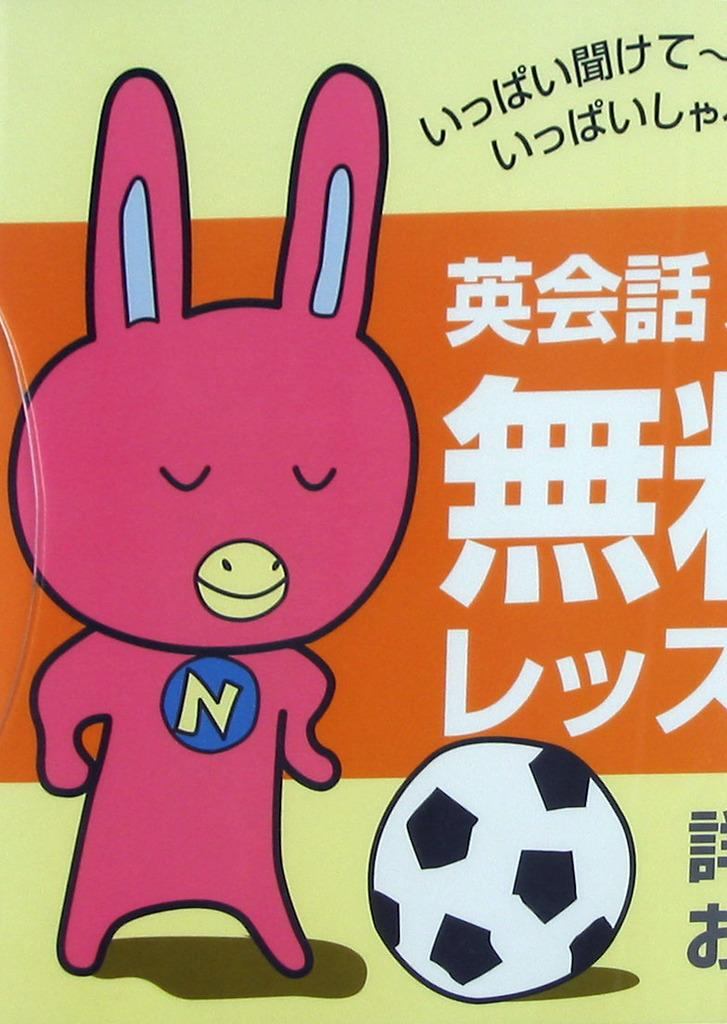What is present on the poster in the image? There is a poster in the image, which contains text and an image. Can you describe the image on the poster? Unfortunately, the facts provided do not give any details about the image on the poster. What type of information might be conveyed through the text on the poster? The text on the poster might convey information about a product, event, or idea, but without more context, it's difficult to determine the specific content. What type of beef is being cooked by the fireman in the image? There is no beef or fireman present in the image. Can you tell me how many chess pieces are visible on the poster? Unfortunately, the facts provided do not give any details about the image on the poster, so we cannot determine the number of chess pieces visible. 